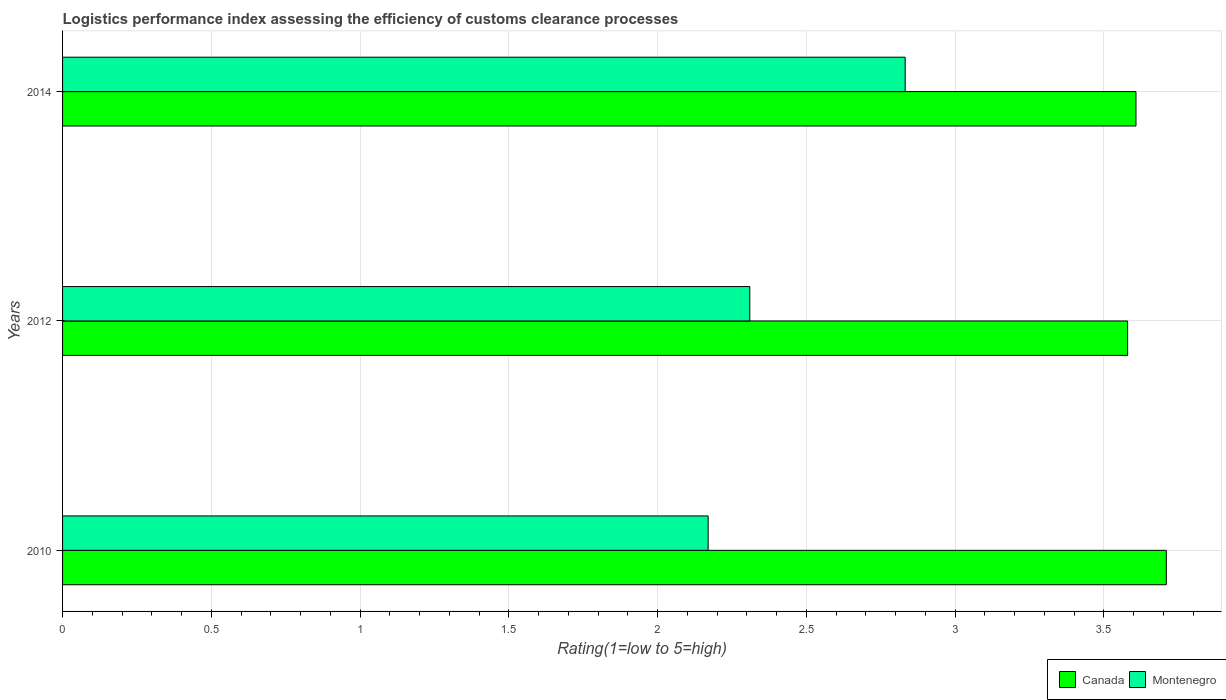How many groups of bars are there?
Keep it short and to the point. 3. How many bars are there on the 1st tick from the bottom?
Ensure brevity in your answer.  2. What is the label of the 1st group of bars from the top?
Offer a very short reply. 2014. In how many cases, is the number of bars for a given year not equal to the number of legend labels?
Keep it short and to the point. 0. What is the Logistic performance index in Montenegro in 2010?
Your answer should be very brief. 2.17. Across all years, what is the maximum Logistic performance index in Montenegro?
Provide a succinct answer. 2.83. Across all years, what is the minimum Logistic performance index in Canada?
Your answer should be compact. 3.58. What is the total Logistic performance index in Canada in the graph?
Offer a terse response. 10.9. What is the difference between the Logistic performance index in Montenegro in 2012 and that in 2014?
Keep it short and to the point. -0.52. What is the difference between the Logistic performance index in Canada in 2010 and the Logistic performance index in Montenegro in 2014?
Offer a terse response. 0.88. What is the average Logistic performance index in Montenegro per year?
Ensure brevity in your answer.  2.44. In the year 2010, what is the difference between the Logistic performance index in Canada and Logistic performance index in Montenegro?
Provide a succinct answer. 1.54. In how many years, is the Logistic performance index in Canada greater than 2.4 ?
Make the answer very short. 3. What is the ratio of the Logistic performance index in Canada in 2012 to that in 2014?
Provide a short and direct response. 0.99. What is the difference between the highest and the second highest Logistic performance index in Canada?
Provide a succinct answer. 0.1. What is the difference between the highest and the lowest Logistic performance index in Montenegro?
Provide a short and direct response. 0.66. What does the 1st bar from the top in 2010 represents?
Your response must be concise. Montenegro. Are all the bars in the graph horizontal?
Ensure brevity in your answer.  Yes. How many years are there in the graph?
Offer a terse response. 3. Are the values on the major ticks of X-axis written in scientific E-notation?
Provide a short and direct response. No. Does the graph contain grids?
Keep it short and to the point. Yes. Where does the legend appear in the graph?
Ensure brevity in your answer.  Bottom right. What is the title of the graph?
Your answer should be very brief. Logistics performance index assessing the efficiency of customs clearance processes. What is the label or title of the X-axis?
Your response must be concise. Rating(1=low to 5=high). What is the Rating(1=low to 5=high) in Canada in 2010?
Make the answer very short. 3.71. What is the Rating(1=low to 5=high) in Montenegro in 2010?
Ensure brevity in your answer.  2.17. What is the Rating(1=low to 5=high) of Canada in 2012?
Give a very brief answer. 3.58. What is the Rating(1=low to 5=high) of Montenegro in 2012?
Keep it short and to the point. 2.31. What is the Rating(1=low to 5=high) of Canada in 2014?
Ensure brevity in your answer.  3.61. What is the Rating(1=low to 5=high) in Montenegro in 2014?
Your response must be concise. 2.83. Across all years, what is the maximum Rating(1=low to 5=high) of Canada?
Provide a succinct answer. 3.71. Across all years, what is the maximum Rating(1=low to 5=high) in Montenegro?
Offer a very short reply. 2.83. Across all years, what is the minimum Rating(1=low to 5=high) of Canada?
Make the answer very short. 3.58. Across all years, what is the minimum Rating(1=low to 5=high) in Montenegro?
Provide a succinct answer. 2.17. What is the total Rating(1=low to 5=high) in Canada in the graph?
Provide a succinct answer. 10.9. What is the total Rating(1=low to 5=high) in Montenegro in the graph?
Keep it short and to the point. 7.31. What is the difference between the Rating(1=low to 5=high) of Canada in 2010 and that in 2012?
Offer a very short reply. 0.13. What is the difference between the Rating(1=low to 5=high) in Montenegro in 2010 and that in 2012?
Offer a very short reply. -0.14. What is the difference between the Rating(1=low to 5=high) of Canada in 2010 and that in 2014?
Make the answer very short. 0.1. What is the difference between the Rating(1=low to 5=high) of Montenegro in 2010 and that in 2014?
Give a very brief answer. -0.66. What is the difference between the Rating(1=low to 5=high) in Canada in 2012 and that in 2014?
Offer a very short reply. -0.03. What is the difference between the Rating(1=low to 5=high) in Montenegro in 2012 and that in 2014?
Offer a very short reply. -0.52. What is the difference between the Rating(1=low to 5=high) of Canada in 2010 and the Rating(1=low to 5=high) of Montenegro in 2012?
Keep it short and to the point. 1.4. What is the difference between the Rating(1=low to 5=high) in Canada in 2010 and the Rating(1=low to 5=high) in Montenegro in 2014?
Give a very brief answer. 0.88. What is the difference between the Rating(1=low to 5=high) in Canada in 2012 and the Rating(1=low to 5=high) in Montenegro in 2014?
Offer a very short reply. 0.75. What is the average Rating(1=low to 5=high) in Canada per year?
Ensure brevity in your answer.  3.63. What is the average Rating(1=low to 5=high) in Montenegro per year?
Your answer should be very brief. 2.44. In the year 2010, what is the difference between the Rating(1=low to 5=high) of Canada and Rating(1=low to 5=high) of Montenegro?
Provide a short and direct response. 1.54. In the year 2012, what is the difference between the Rating(1=low to 5=high) of Canada and Rating(1=low to 5=high) of Montenegro?
Provide a succinct answer. 1.27. In the year 2014, what is the difference between the Rating(1=low to 5=high) in Canada and Rating(1=low to 5=high) in Montenegro?
Offer a terse response. 0.78. What is the ratio of the Rating(1=low to 5=high) in Canada in 2010 to that in 2012?
Your answer should be compact. 1.04. What is the ratio of the Rating(1=low to 5=high) in Montenegro in 2010 to that in 2012?
Offer a terse response. 0.94. What is the ratio of the Rating(1=low to 5=high) of Canada in 2010 to that in 2014?
Your answer should be compact. 1.03. What is the ratio of the Rating(1=low to 5=high) of Montenegro in 2010 to that in 2014?
Offer a terse response. 0.77. What is the ratio of the Rating(1=low to 5=high) in Montenegro in 2012 to that in 2014?
Offer a terse response. 0.82. What is the difference between the highest and the second highest Rating(1=low to 5=high) of Canada?
Offer a very short reply. 0.1. What is the difference between the highest and the second highest Rating(1=low to 5=high) in Montenegro?
Offer a very short reply. 0.52. What is the difference between the highest and the lowest Rating(1=low to 5=high) of Canada?
Provide a succinct answer. 0.13. What is the difference between the highest and the lowest Rating(1=low to 5=high) of Montenegro?
Offer a very short reply. 0.66. 